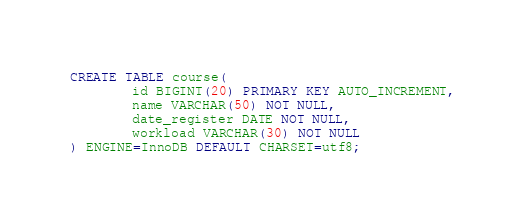<code> <loc_0><loc_0><loc_500><loc_500><_SQL_>CREATE TABLE course(
        id BIGINT(20) PRIMARY KEY AUTO_INCREMENT,
        name VARCHAR(50) NOT NULL,
        date_register DATE NOT NULL,
        workload VARCHAR(30) NOT NULL
) ENGINE=InnoDB DEFAULT CHARSET=utf8;


</code> 